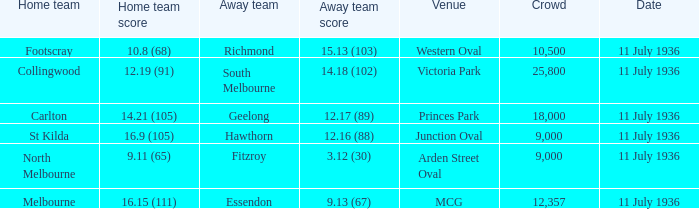At the mcg venue, what was the least crowded event? 12357.0. 